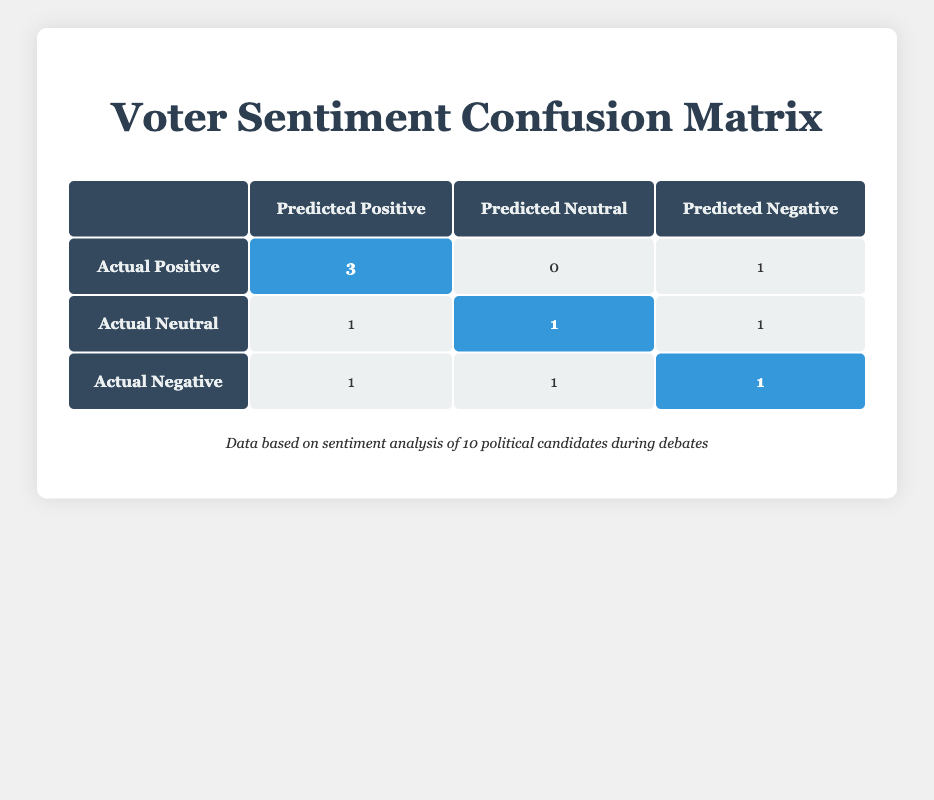What is the total number of predictions for the Positive sentiment? To find the total number of predictions for Positive sentiment, we can look at the 'Actual Positive' row in the table. The values in that row are: 3 (predicted Positive), 0 (predicted Neutral), and 1 (predicted Negative). Summing these gives 3 + 0 + 1 = 4.
Answer: 4 How many candidates had their sentiment predicted as Negative? By examining the entire matrix, we can look at the column for 'Predicted Negative.' The values are 1 (from 'Actual Positive'), 1 (from 'Actual Neutral'), and 1 (from 'Actual Negative'). Adding these together, we get 1 + 1 + 1 = 3 candidates predicted as Negative.
Answer: 3 What percentage of the actual Positive sentiments were correctly predicted? Based on the table, there are 3 actual Positive sentiments predicted as Positive, and there were a total of 4 actual Positive sentiments (3 predicted Positive and 1 predicted Negative). The percentage is calculated as (3 / 4) * 100 = 75%.
Answer: 75% Did any candidate with an actual Neutral sentiment get predicted incorrectly? To assess this, we need to check the 'Actual Neutral' row. Its predictions were: 1 predicted Positive, 1 predicted Neutral, and 1 predicted Negative. Since there are predictions made other than Neutral, it means some were predicted incorrectly.
Answer: Yes Which sentiment had the highest number of correct predictions? The 'Actual Positive' category had 3 correct predictions (3 predicted Positive). In 'Actual Neutral,' there was 1 correct prediction (1 predicted Neutral). In 'Actual Negative,' there was 1 correct prediction as well. Thus, 'Actual Positive' has the highest count of correct predictions.
Answer: Positive 